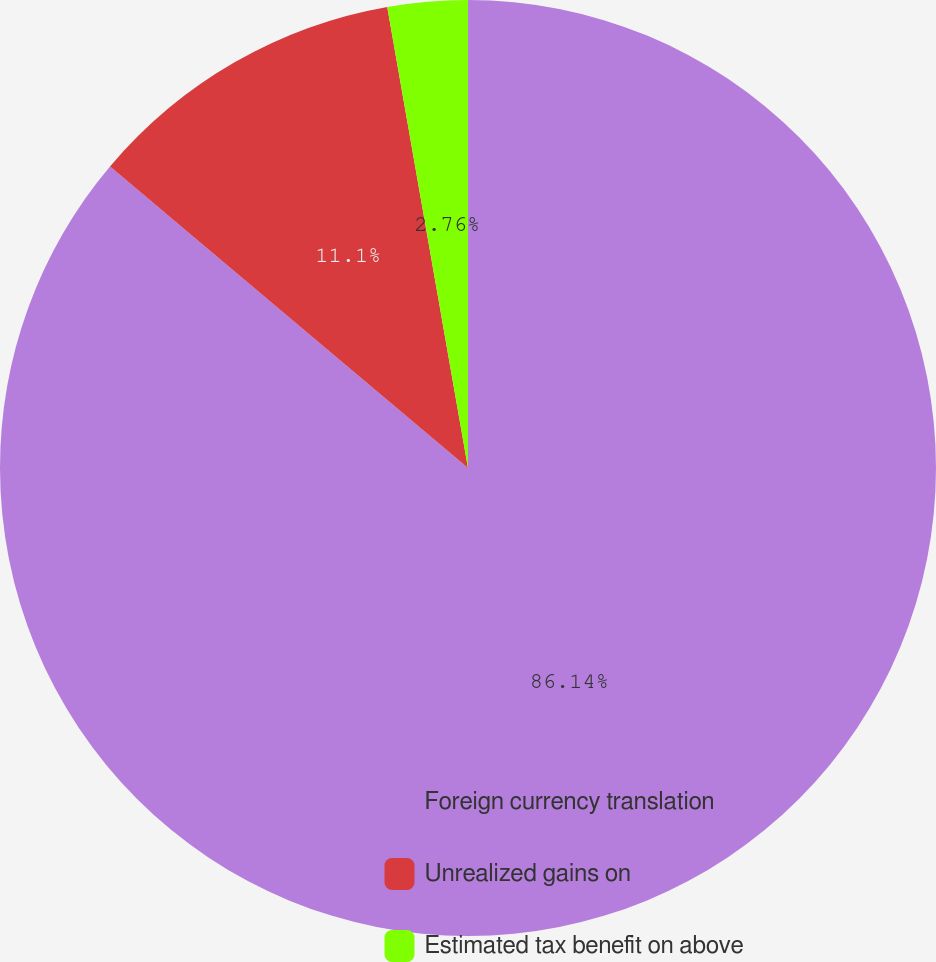Convert chart to OTSL. <chart><loc_0><loc_0><loc_500><loc_500><pie_chart><fcel>Foreign currency translation<fcel>Unrealized gains on<fcel>Estimated tax benefit on above<nl><fcel>86.13%<fcel>11.1%<fcel>2.76%<nl></chart> 